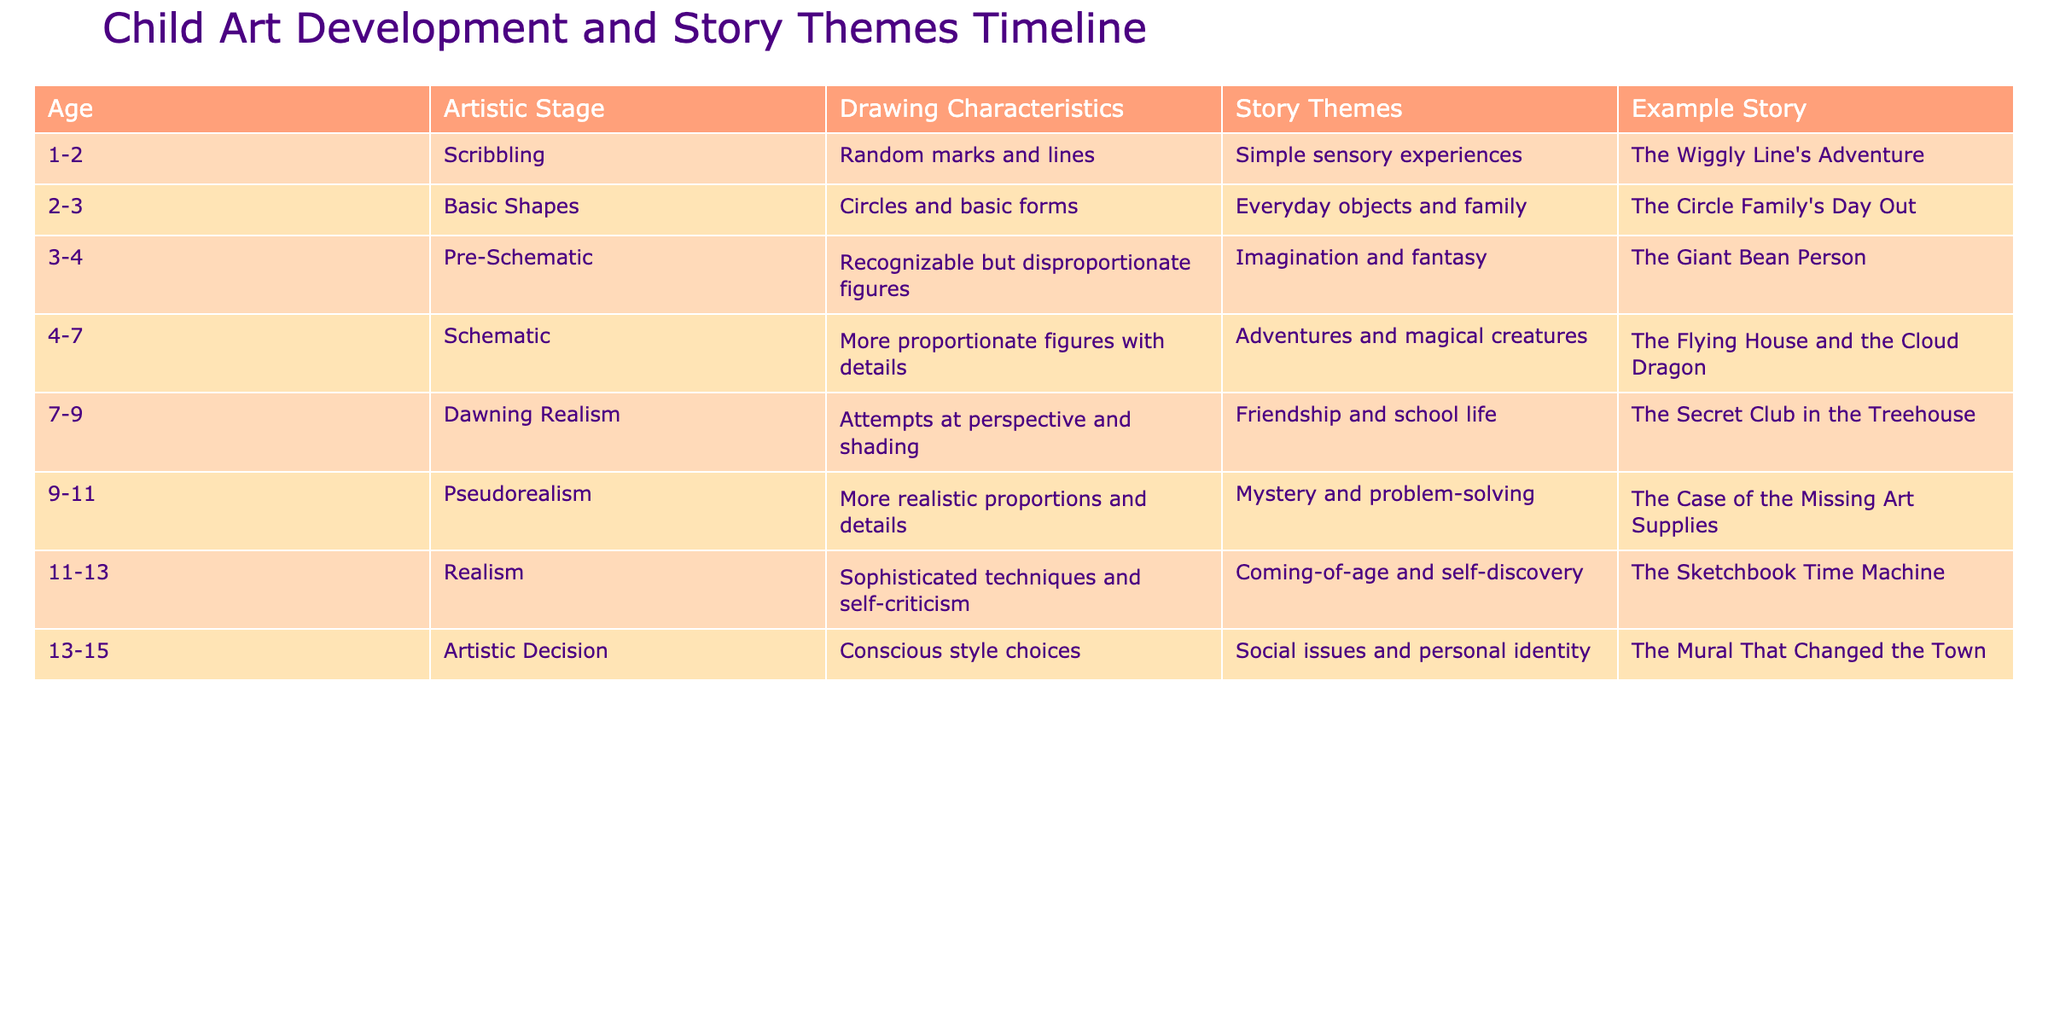What is the artistic stage for a child aged 4 to 7? According to the table, the artistic stage for this age range is referred to as "Schematic." This is explicitly listed in the "Artistic Stage" column for the age range of 4-7.
Answer: Schematic What story theme corresponds to the drawing characteristics of "More proportionate figures with details"? The drawing characteristics "More proportionate figures with details" relate to the artistic stage of 4-7, which is "Schematic." I look at the "Story Themes" column for this artist stage and find the corresponding theme is "Adventures and magical creatures."
Answer: Adventures and magical creatures At what age does a child typically begin to show attempts at perspective and shading? From the table, the age range when children typically begin to show these attempts falls between 7-9 years. It’s indicated in the "Age" column, aligned with the artistic stage "Dawning Realism."
Answer: 7-9 Is "The Sketchbook Time Machine" associated with a stage of artistic expression focused on social issues? Reviewing the table, "The Sketchbook Time Machine" is linked to the artistic stage of 11-13. The corresponding story themes for this stage include "Coming-of-age and self-discovery," not social issues. Therefore, the statement is false.
Answer: No What is the average age range for children in the "Pseudorealism" artistic stage? The "Pseudorealism" artistic stage corresponds to ages 9-11, as noted in the "Age" column. To determine the average of this range, I add 9 and 11, which results in 20, then divide by 2, yielding an average age of 10.
Answer: 10 Which story from the table is centered around the theme of friendship and school life? By examining the "Story Themes" column, I find that "Friendship and school life" aligns with the artistic stage of 7-9 years, and the corresponding story listed is "The Secret Club in the Treehouse."
Answer: The Secret Club in the Treehouse How many stages involve more realistic proportions and details, and what are they called? The "Pseudorealism" (9-11) and "Realism" (11-13) stages both involve more realistic proportions and details. Therefore, there are two stages, and they are called "Pseudorealism" and "Realism."
Answer: Two stages: Pseudorealism and Realism Is the story "The Wiggly Line's Adventure" associated with sensory experiences? Looking at the "Story Themes" column, "The Wiggly Line's Adventure" aligns with the artistic stage "Scribbling" for ages 1-2, which is described as having simple sensory experiences. Hence, the statement is true.
Answer: Yes How many artistic stages include the word 'Artistic' in their title? The table shows that there is only one artistic stage with the word 'Artistic' in its title, which is "Artistic Decision." Thus, the answer is one.
Answer: One 